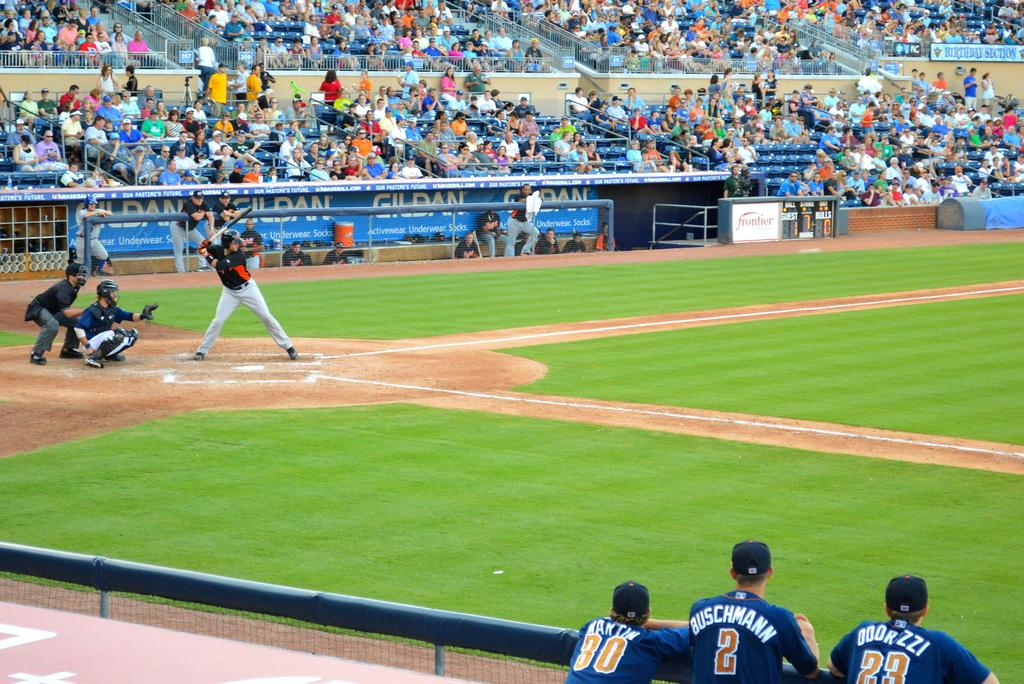<image>
Present a compact description of the photo's key features. Baseball players with blue jerseys on with Buschmann in white on the back. 